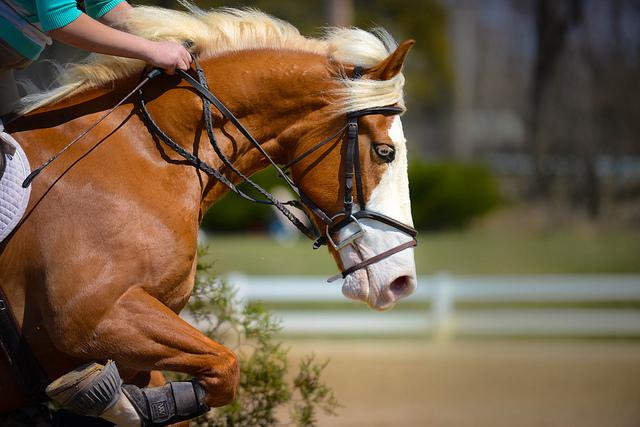What color is the harness?
Short answer required. Black. What color is the horse's mouth?
Write a very short answer. White. What color are the rider's shirt sleeves?
Write a very short answer. Green. Is the horse hungry?
Concise answer only. No. What is the rider holding?
Be succinct. Reins. 